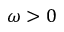<formula> <loc_0><loc_0><loc_500><loc_500>\omega > 0</formula> 